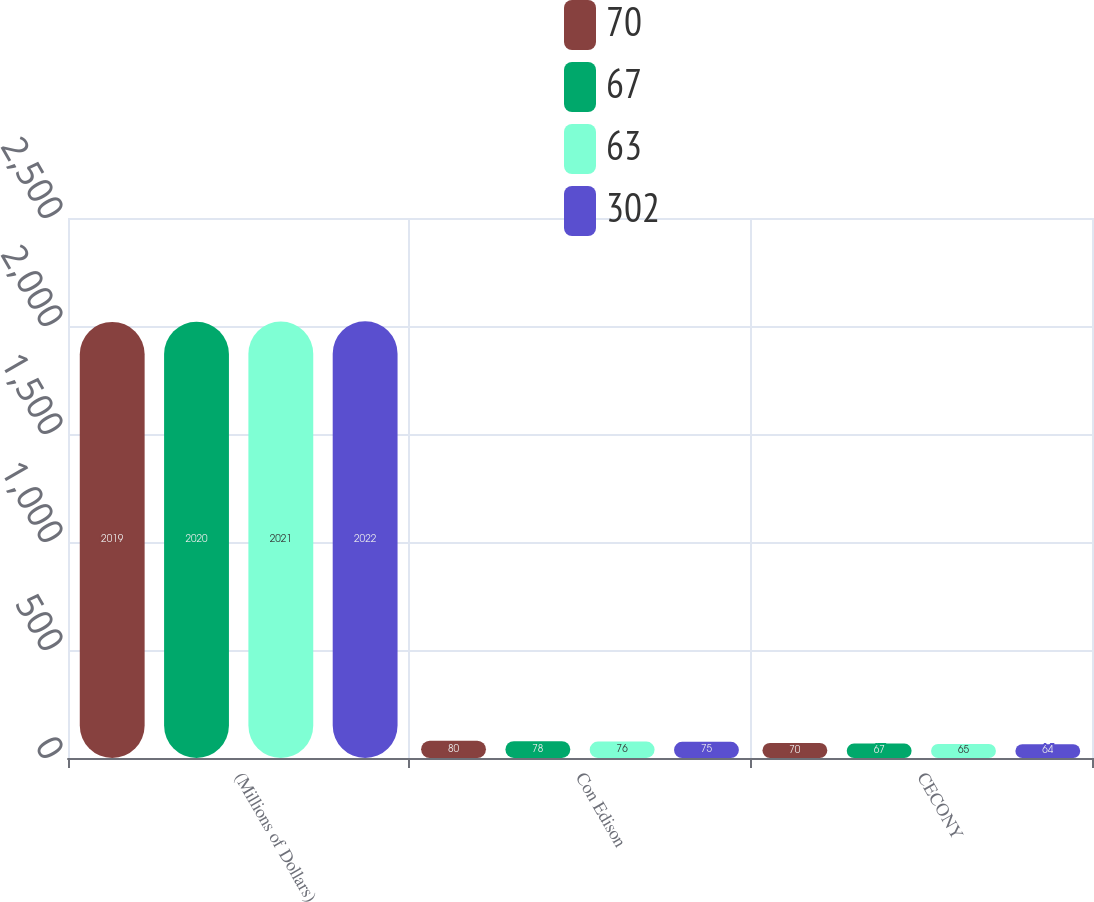Convert chart to OTSL. <chart><loc_0><loc_0><loc_500><loc_500><stacked_bar_chart><ecel><fcel>(Millions of Dollars)<fcel>Con Edison<fcel>CECONY<nl><fcel>70<fcel>2019<fcel>80<fcel>70<nl><fcel>67<fcel>2020<fcel>78<fcel>67<nl><fcel>63<fcel>2021<fcel>76<fcel>65<nl><fcel>302<fcel>2022<fcel>75<fcel>64<nl></chart> 